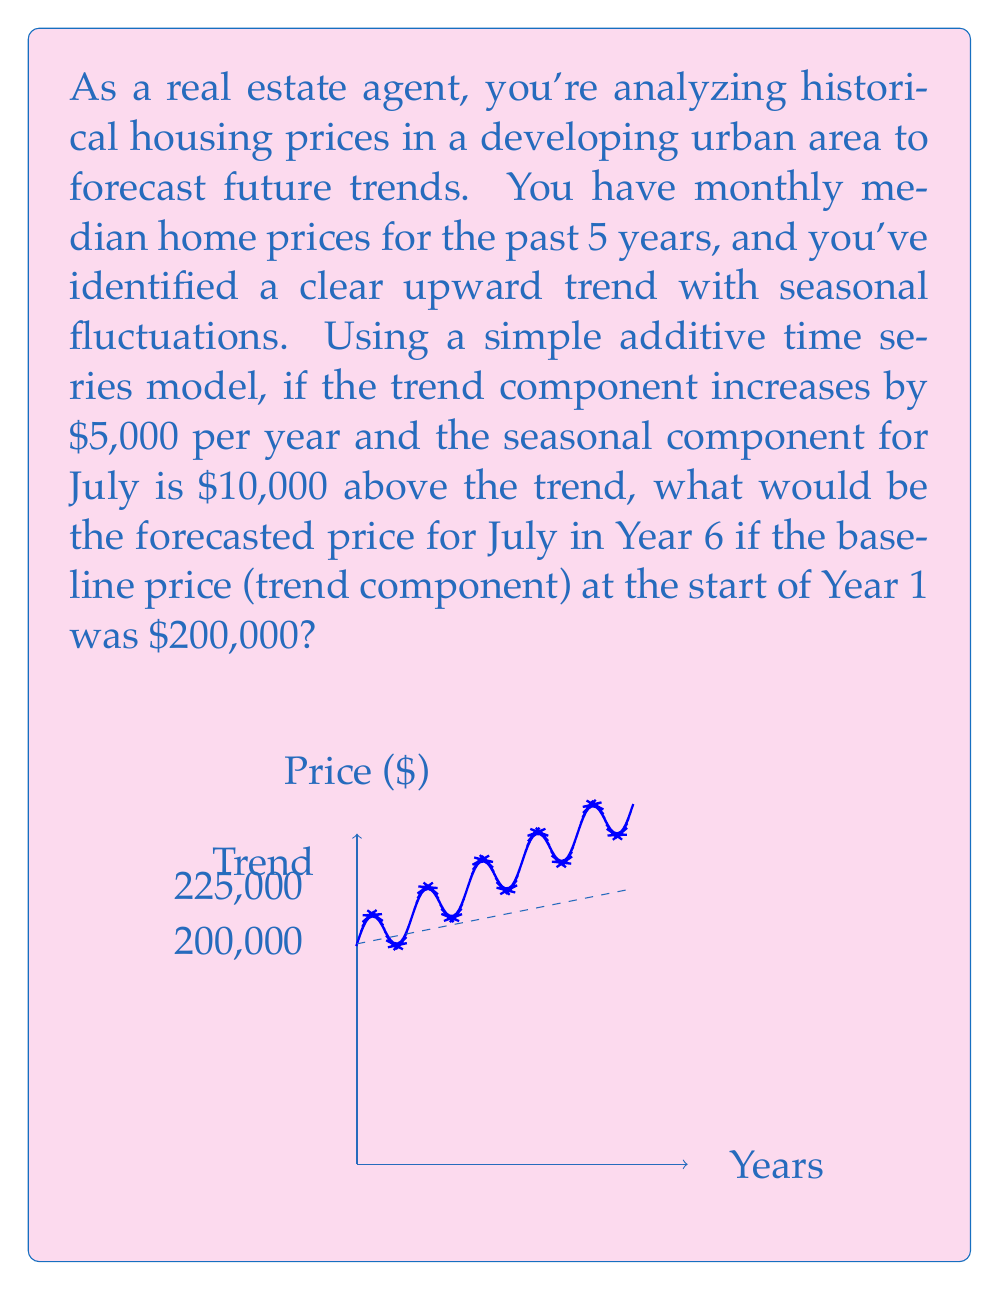Give your solution to this math problem. Let's break this down step-by-step:

1) The additive time series model is represented as:
   $Y_t = T_t + S_t + E_t$
   where $Y_t$ is the observed value, $T_t$ is the trend component, $S_t$ is the seasonal component, and $E_t$ is the error term (which we'll ignore for this forecast).

2) The trend component $T_t$ is given by:
   $T_t = 200000 + 5000t$
   where $t$ is the number of years since the start.

3) For July in Year 6, $t = 5$ (as we start counting from 0 for Year 1).

4) Calculate the trend component for Year 6:
   $T_6 = 200000 + 5000(5) = 225000$

5) The seasonal component for July is given as $10,000 above the trend:
   $S_{July} = 10000$

6) Combine the trend and seasonal components:
   $Y_6 = T_6 + S_{July} = 225000 + 10000 = 235000$

Therefore, the forecasted price for July in Year 6 would be $235,000.
Answer: $235,000 